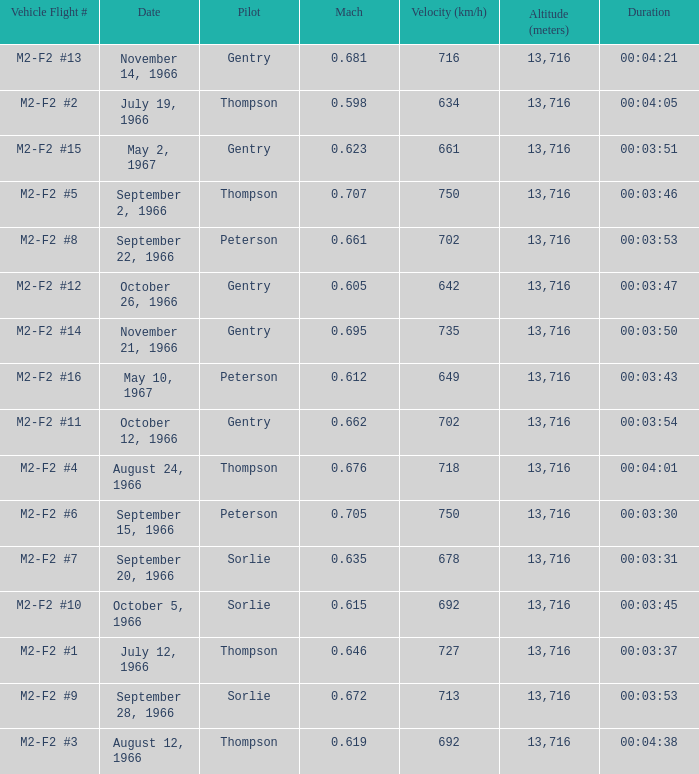What Vehicle Flight # has Pilot Peterson and Velocity (km/h) of 649? M2-F2 #16. 